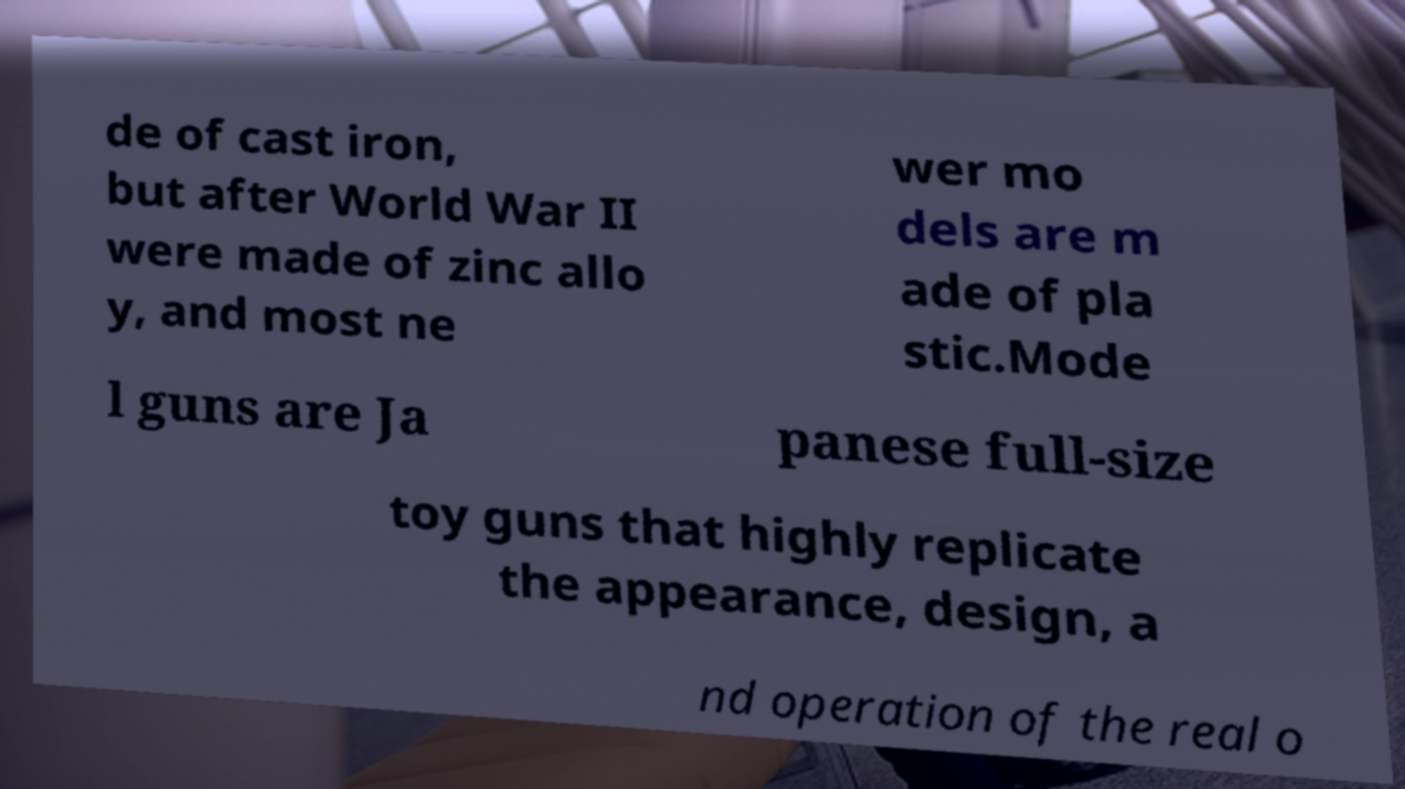Please read and relay the text visible in this image. What does it say? de of cast iron, but after World War II were made of zinc allo y, and most ne wer mo dels are m ade of pla stic.Mode l guns are Ja panese full-size toy guns that highly replicate the appearance, design, a nd operation of the real o 